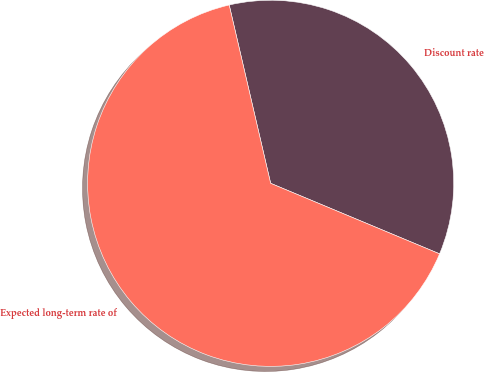Convert chart to OTSL. <chart><loc_0><loc_0><loc_500><loc_500><pie_chart><fcel>Discount rate<fcel>Expected long-term rate of<nl><fcel>34.93%<fcel>65.07%<nl></chart> 